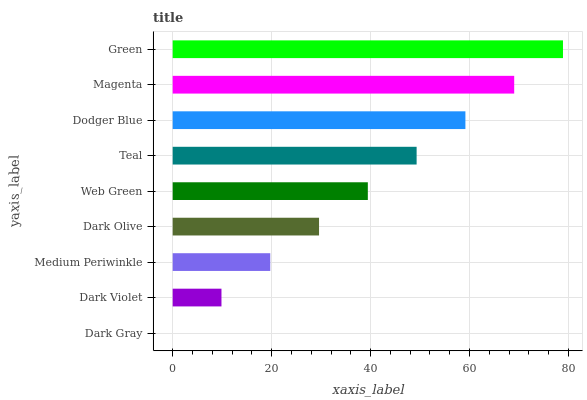Is Dark Gray the minimum?
Answer yes or no. Yes. Is Green the maximum?
Answer yes or no. Yes. Is Dark Violet the minimum?
Answer yes or no. No. Is Dark Violet the maximum?
Answer yes or no. No. Is Dark Violet greater than Dark Gray?
Answer yes or no. Yes. Is Dark Gray less than Dark Violet?
Answer yes or no. Yes. Is Dark Gray greater than Dark Violet?
Answer yes or no. No. Is Dark Violet less than Dark Gray?
Answer yes or no. No. Is Web Green the high median?
Answer yes or no. Yes. Is Web Green the low median?
Answer yes or no. Yes. Is Teal the high median?
Answer yes or no. No. Is Dark Gray the low median?
Answer yes or no. No. 